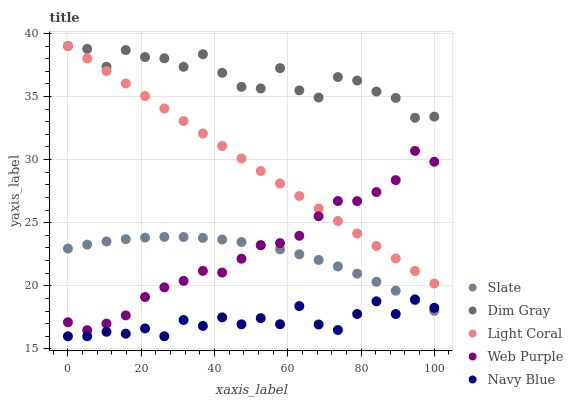Does Navy Blue have the minimum area under the curve?
Answer yes or no. Yes. Does Dim Gray have the maximum area under the curve?
Answer yes or no. Yes. Does Slate have the minimum area under the curve?
Answer yes or no. No. Does Slate have the maximum area under the curve?
Answer yes or no. No. Is Light Coral the smoothest?
Answer yes or no. Yes. Is Dim Gray the roughest?
Answer yes or no. Yes. Is Navy Blue the smoothest?
Answer yes or no. No. Is Navy Blue the roughest?
Answer yes or no. No. Does Navy Blue have the lowest value?
Answer yes or no. Yes. Does Slate have the lowest value?
Answer yes or no. No. Does Dim Gray have the highest value?
Answer yes or no. Yes. Does Slate have the highest value?
Answer yes or no. No. Is Navy Blue less than Dim Gray?
Answer yes or no. Yes. Is Dim Gray greater than Slate?
Answer yes or no. Yes. Does Light Coral intersect Dim Gray?
Answer yes or no. Yes. Is Light Coral less than Dim Gray?
Answer yes or no. No. Is Light Coral greater than Dim Gray?
Answer yes or no. No. Does Navy Blue intersect Dim Gray?
Answer yes or no. No. 